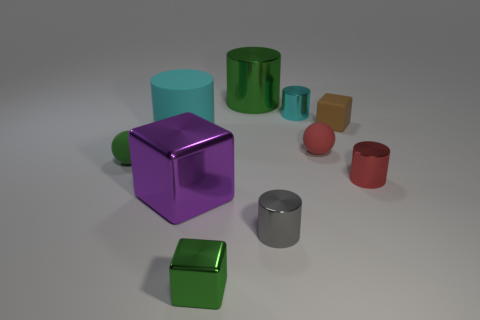Are there the same number of small red rubber things that are on the left side of the large green metallic cylinder and tiny objects in front of the small gray shiny thing?
Your response must be concise. No. Are there any small objects to the right of the rubber cylinder behind the small gray metal cylinder?
Provide a succinct answer. Yes. What is the shape of the small brown thing that is the same material as the green ball?
Offer a very short reply. Cube. Is there any other thing of the same color as the small metallic block?
Provide a succinct answer. Yes. The small green thing in front of the big purple thing in front of the red shiny thing is made of what material?
Offer a very short reply. Metal. Are there any other things that have the same shape as the large purple shiny object?
Your answer should be compact. Yes. What number of other things are the same shape as the tiny green shiny thing?
Provide a succinct answer. 2. The small rubber thing that is behind the green rubber ball and on the left side of the tiny brown cube has what shape?
Your answer should be compact. Sphere. There is a cyan object in front of the brown rubber cube; what size is it?
Keep it short and to the point. Large. Do the red shiny cylinder and the purple metal cube have the same size?
Give a very brief answer. No. 